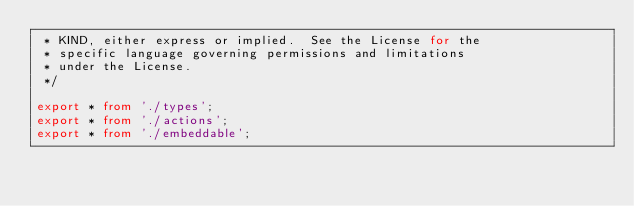Convert code to text. <code><loc_0><loc_0><loc_500><loc_500><_TypeScript_> * KIND, either express or implied.  See the License for the
 * specific language governing permissions and limitations
 * under the License.
 */

export * from './types';
export * from './actions';
export * from './embeddable';
</code> 